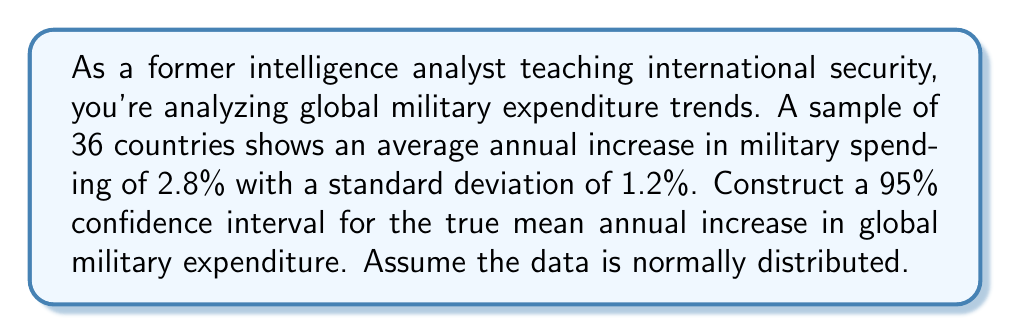Can you solve this math problem? To construct a 95% confidence interval, we'll follow these steps:

1. Identify the relevant information:
   - Sample size (n) = 36
   - Sample mean ($\bar{x}$) = 2.8%
   - Sample standard deviation (s) = 1.2%
   - Confidence level = 95%

2. Determine the critical value:
   For a 95% confidence interval with 35 degrees of freedom (n-1), we use the t-distribution. The critical value is $t_{0.025, 35} = 2.030$.

3. Calculate the margin of error:
   Margin of error = $t_{0.025, 35} \cdot \frac{s}{\sqrt{n}}$
   $$ \text{Margin of error} = 2.030 \cdot \frac{1.2}{\sqrt{36}} = 2.030 \cdot 0.2 = 0.406 $$

4. Construct the confidence interval:
   Lower bound = $\bar{x} - \text{Margin of error}$
   Upper bound = $\bar{x} + \text{Margin of error}$

   $$ \text{CI} = (2.8 - 0.406, 2.8 + 0.406) = (2.394, 3.206) $$

5. Interpret the result:
   We can be 95% confident that the true mean annual increase in global military expenditure falls between 2.394% and 3.206%.
Answer: (2.394%, 3.206%) 